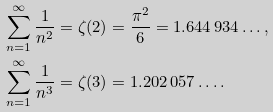<formula> <loc_0><loc_0><loc_500><loc_500>& \sum _ { n = 1 } ^ { \infty } \frac { 1 } { n ^ { 2 } } = \zeta ( 2 ) = \frac { \pi ^ { 2 } } { 6 } = 1 . 6 4 4 \, 9 3 4 \dots , \\ & \sum _ { n = 1 } ^ { \infty } \frac { 1 } { n ^ { 3 } } = \zeta ( 3 ) = 1 . 2 0 2 \, 0 5 7 \dots .</formula> 